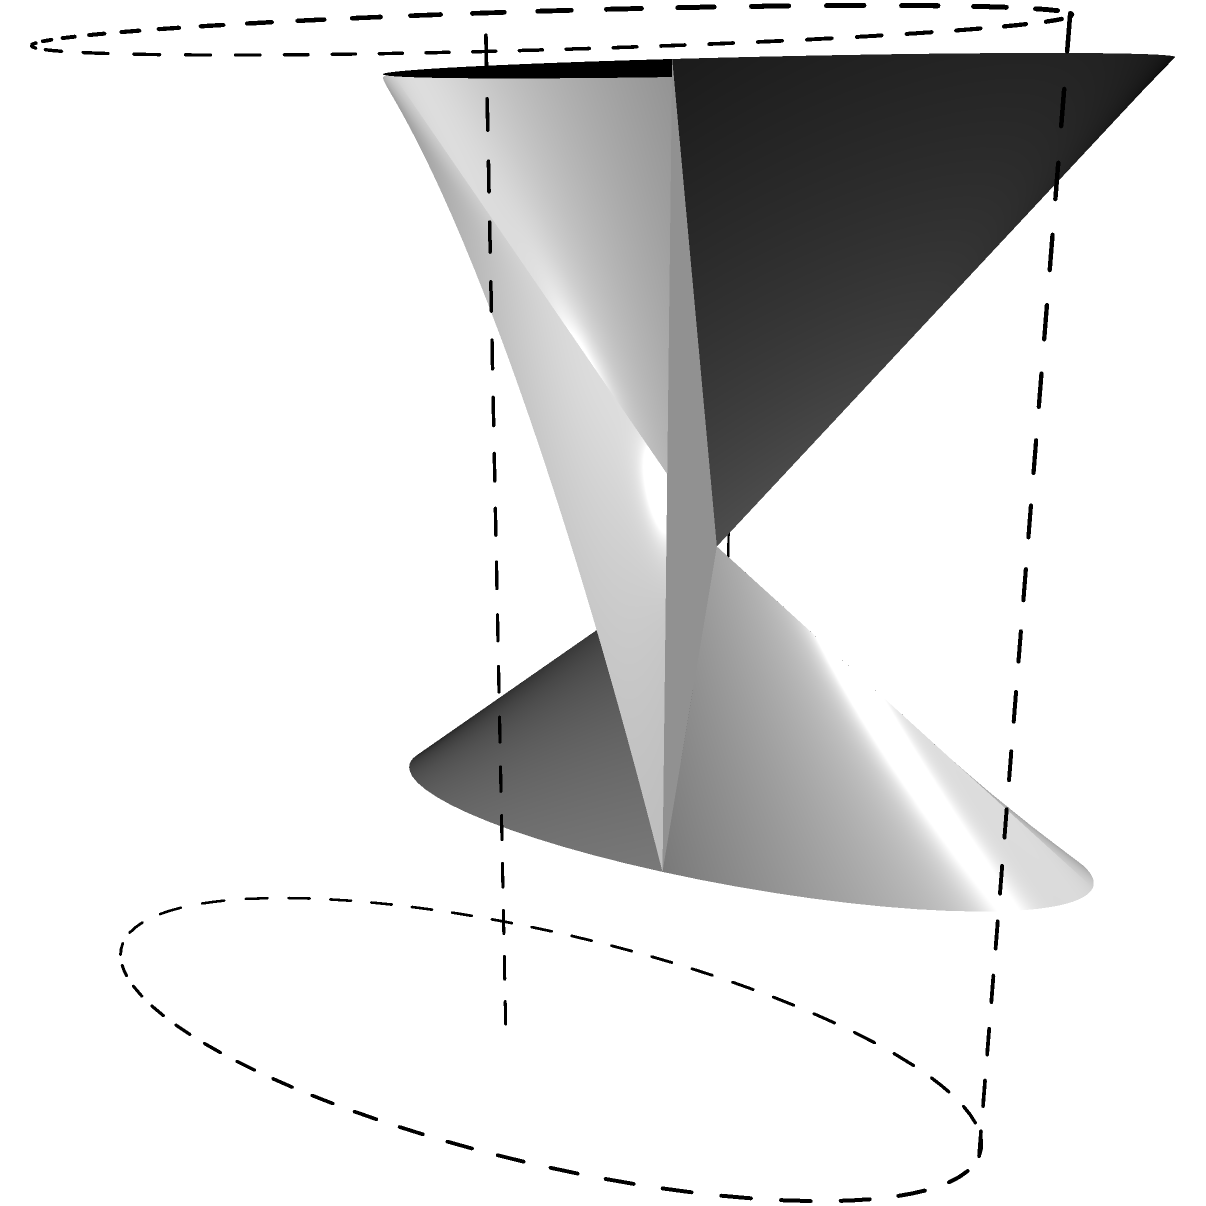In your wine cellar, you have stacked 20 identical cylindrical wine barrels. Each barrel has a radius of 0.5 meters and a height of 1.2 meters. What is the total surface area of all the barrels combined, including the top and bottom circular faces? Round your answer to the nearest square meter. Let's approach this step-by-step:

1) For a single cylindrical barrel, we need to calculate:
   a) The area of the curved surface (lateral area)
   b) The area of the top and bottom circular faces

2) The formula for the lateral area of a cylinder is:
   $A_{lateral} = 2\pi rh$
   where $r$ is the radius and $h$ is the height

3) The formula for the area of a circle is:
   $A_{circle} = \pi r^2$

4) Let's calculate for one barrel:
   a) Lateral area: $A_{lateral} = 2\pi(0.5)(1.2) = 3.77 m^2$
   b) Area of one circular face: $A_{circle} = \pi(0.5)^2 = 0.79 m^2$
   c) Total area of both circular faces: $2(0.79) = 1.58 m^2$
   d) Total surface area of one barrel: $3.77 + 1.58 = 5.35 m^2$

5) For 20 barrels, we multiply the total surface area by 20:
   $20 * 5.35 = 107 m^2$

6) Rounding to the nearest square meter: 107 $m^2$
Answer: 107 $m^2$ 